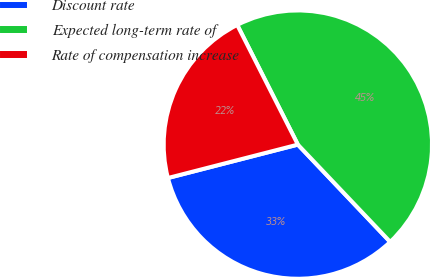Convert chart. <chart><loc_0><loc_0><loc_500><loc_500><pie_chart><fcel>Discount rate<fcel>Expected long-term rate of<fcel>Rate of compensation increase<nl><fcel>33.08%<fcel>45.38%<fcel>21.54%<nl></chart> 